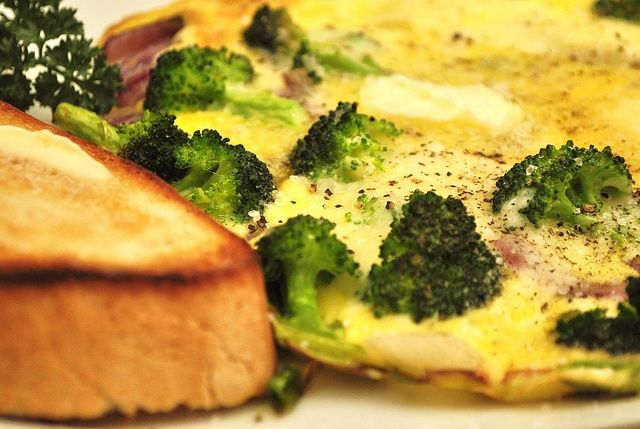Describe the objects in this image and their specific colors. I can see broccoli in black, darkgreen, and khaki tones, broccoli in black and olive tones, broccoli in black, darkgreen, and olive tones, broccoli in black, darkgreen, olive, and khaki tones, and broccoli in black, olive, darkgreen, and khaki tones in this image. 